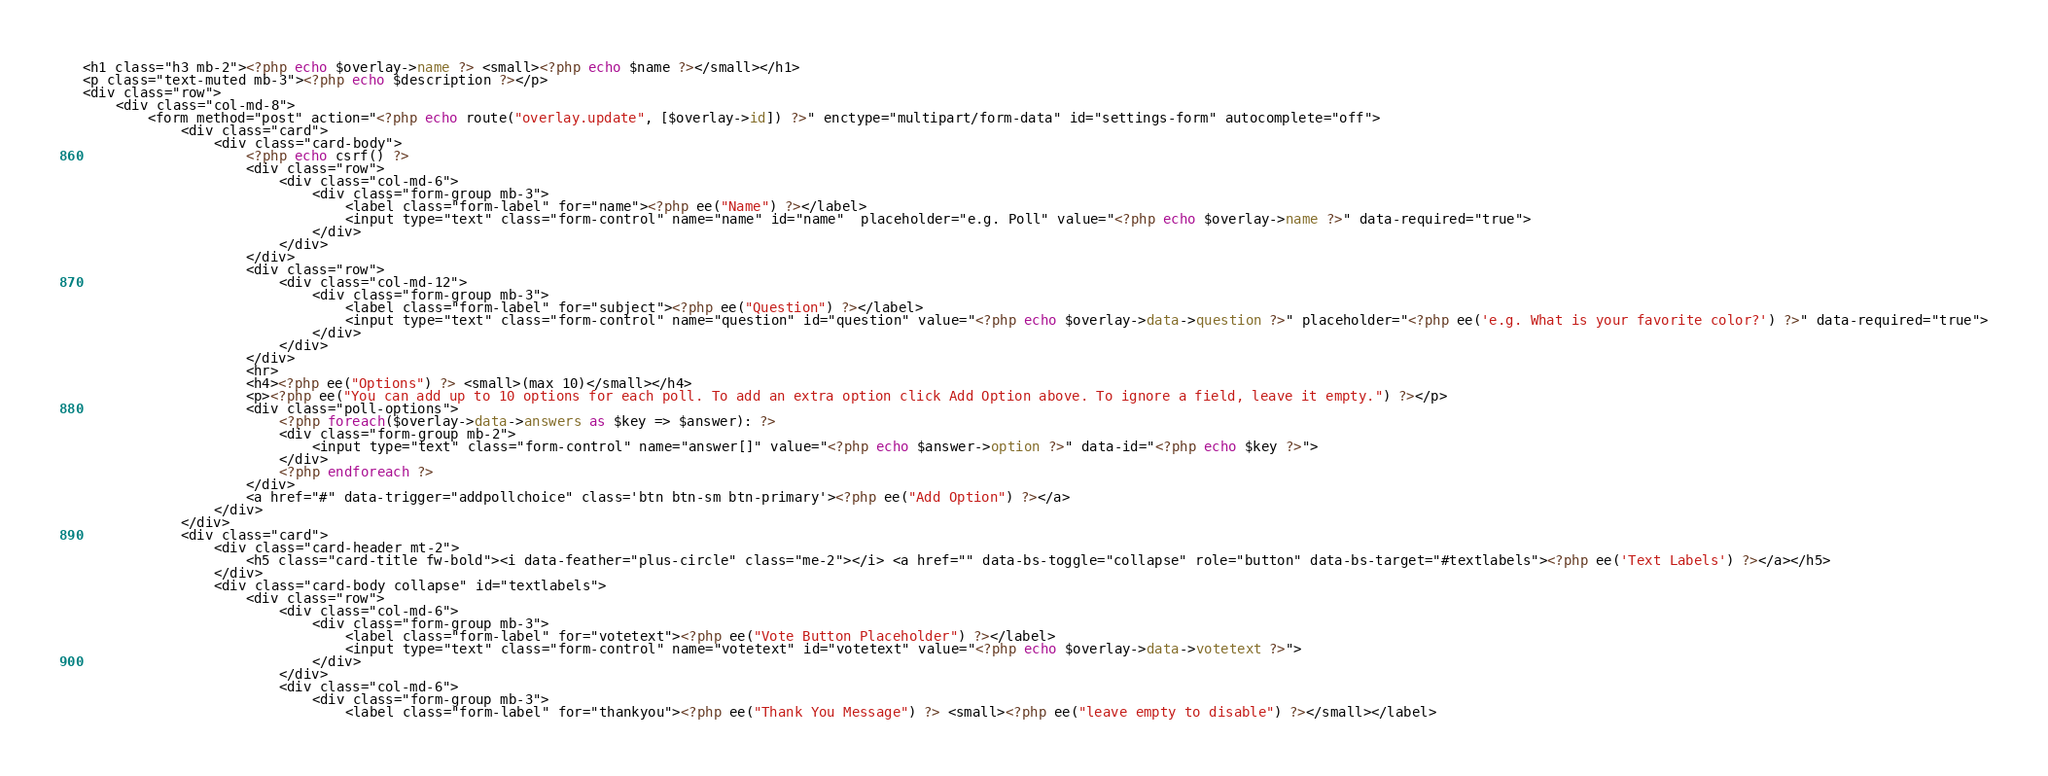Convert code to text. <code><loc_0><loc_0><loc_500><loc_500><_PHP_><h1 class="h3 mb-2"><?php echo $overlay->name ?> <small><?php echo $name ?></small></h1>
<p class="text-muted mb-3"><?php echo $description ?></p>
<div class="row">
    <div class="col-md-8">
		<form method="post" action="<?php echo route("overlay.update", [$overlay->id]) ?>" enctype="multipart/form-data" id="settings-form" autocomplete="off">		
			<div class="card">
				<div class="card-body">
                    <?php echo csrf() ?>
                    <div class="row">
						<div class="col-md-6">
							<div class="form-group mb-3">
								<label class="form-label" for="name"><?php ee("Name") ?></label>
								<input type="text" class="form-control" name="name" id="name"  placeholder="e.g. Poll" value="<?php echo $overlay->name ?>" data-required="true">
							</div>	
						</div>
					</div>
					<div class="row">
						<div class="col-md-12">
							<div class="form-group mb-3">
								<label class="form-label" for="subject"><?php ee("Question") ?></label>
								<input type="text" class="form-control" name="question" id="question" value="<?php echo $overlay->data->question ?>" placeholder="<?php ee('e.g. What is your favorite color?') ?>" data-required="true">
							</div>
						</div>						
					</div>
                    <hr>
                    <h4><?php ee("Options") ?> <small>(max 10)</small></h4>
					<p><?php ee("You can add up to 10 options for each poll. To add an extra option click Add Option above. To ignore a field, leave it empty.") ?></p>
					<div class="poll-options">
                        <?php foreach($overlay->data->answers as $key => $answer): ?>
						<div class="form-group mb-2">
							<input type="text" class="form-control" name="answer[]" value="<?php echo $answer->option ?>" data-id="<?php echo $key ?>">
						</div>						
                        <?php endforeach ?>
					</div>
                    <a href="#" data-trigger="addpollchoice" class='btn btn-sm btn-primary'><?php ee("Add Option") ?></a>
				</div>
			</div>
			<div class="card">
				<div class="card-header mt-2">
					<h5 class="card-title fw-bold"><i data-feather="plus-circle" class="me-2"></i> <a href="" data-bs-toggle="collapse" role="button" data-bs-target="#textlabels"><?php ee('Text Labels') ?></a></h5>
				</div>				
				<div class="card-body collapse" id="textlabels">				
					<div class="row">
						<div class="col-md-6">
							<div class="form-group mb-3">
								<label class="form-label" for="votetext"><?php ee("Vote Button Placeholder") ?></label>
								<input type="text" class="form-control" name="votetext" id="votetext" value="<?php echo $overlay->data->votetext ?>">
							</div>							
						</div>	
                        <div class="col-md-6">
							<div class="form-group mb-3">
								<label class="form-label" for="thankyou"><?php ee("Thank You Message") ?> <small><?php ee("leave empty to disable") ?></small></label></code> 